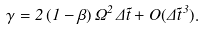Convert formula to latex. <formula><loc_0><loc_0><loc_500><loc_500>\gamma = 2 \, ( 1 - \beta ) \, \Omega ^ { 2 } \, \Delta \tilde { t } + O ( \Delta \tilde { t } ^ { \, 3 } ) .</formula> 